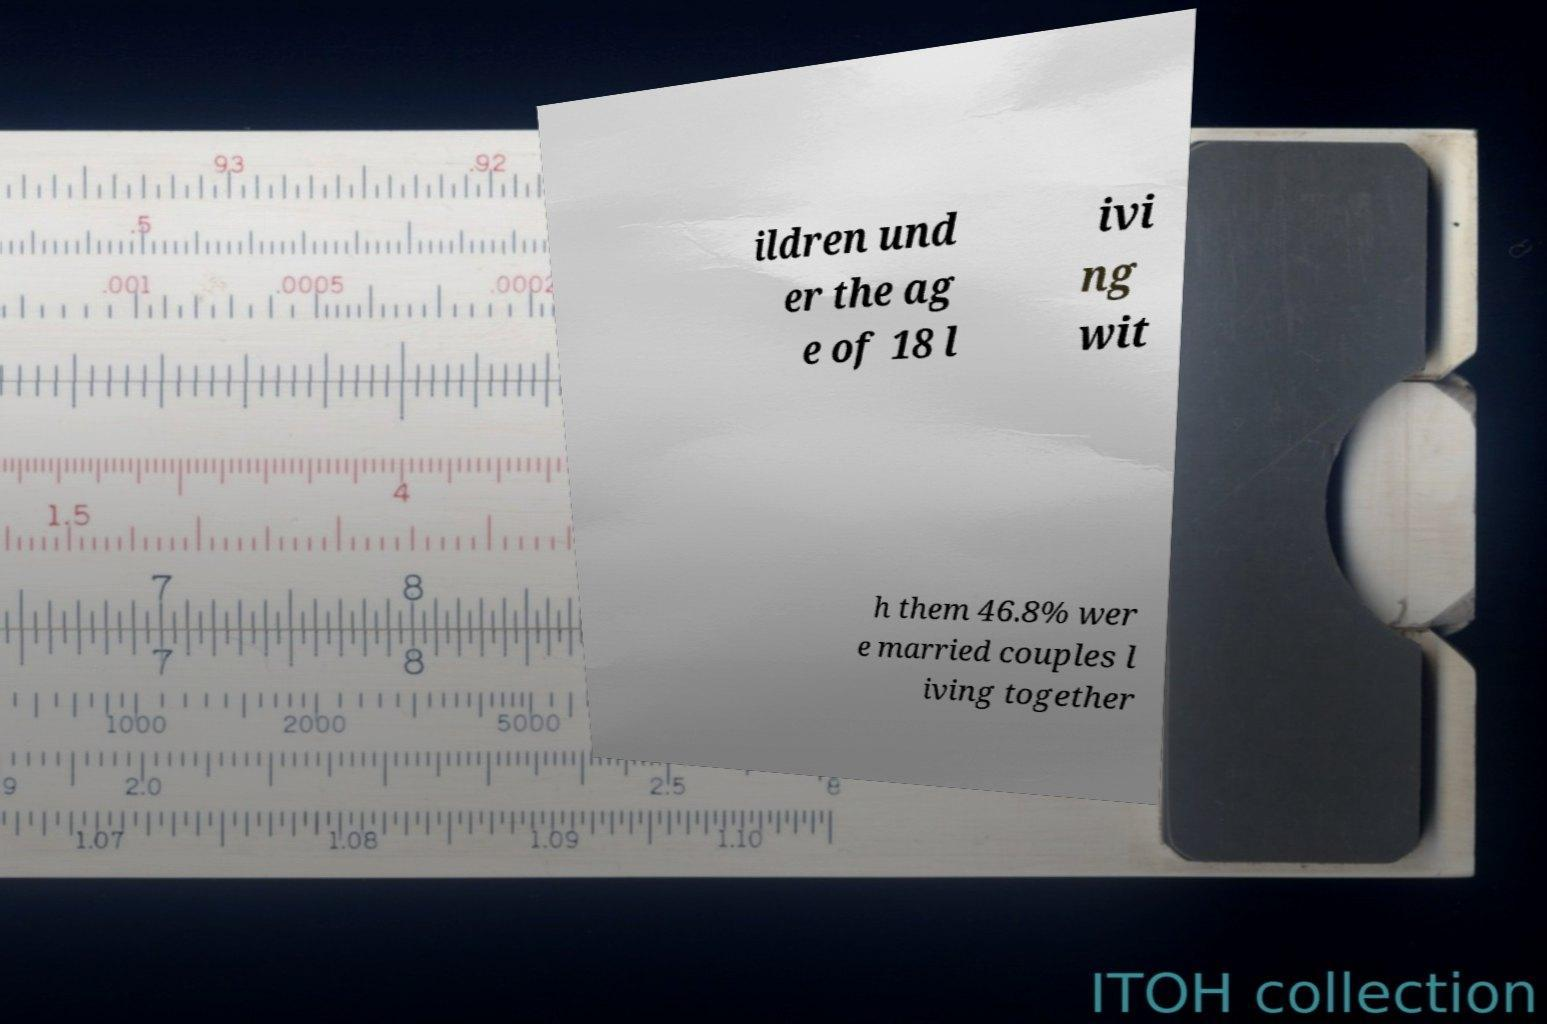I need the written content from this picture converted into text. Can you do that? ildren und er the ag e of 18 l ivi ng wit h them 46.8% wer e married couples l iving together 